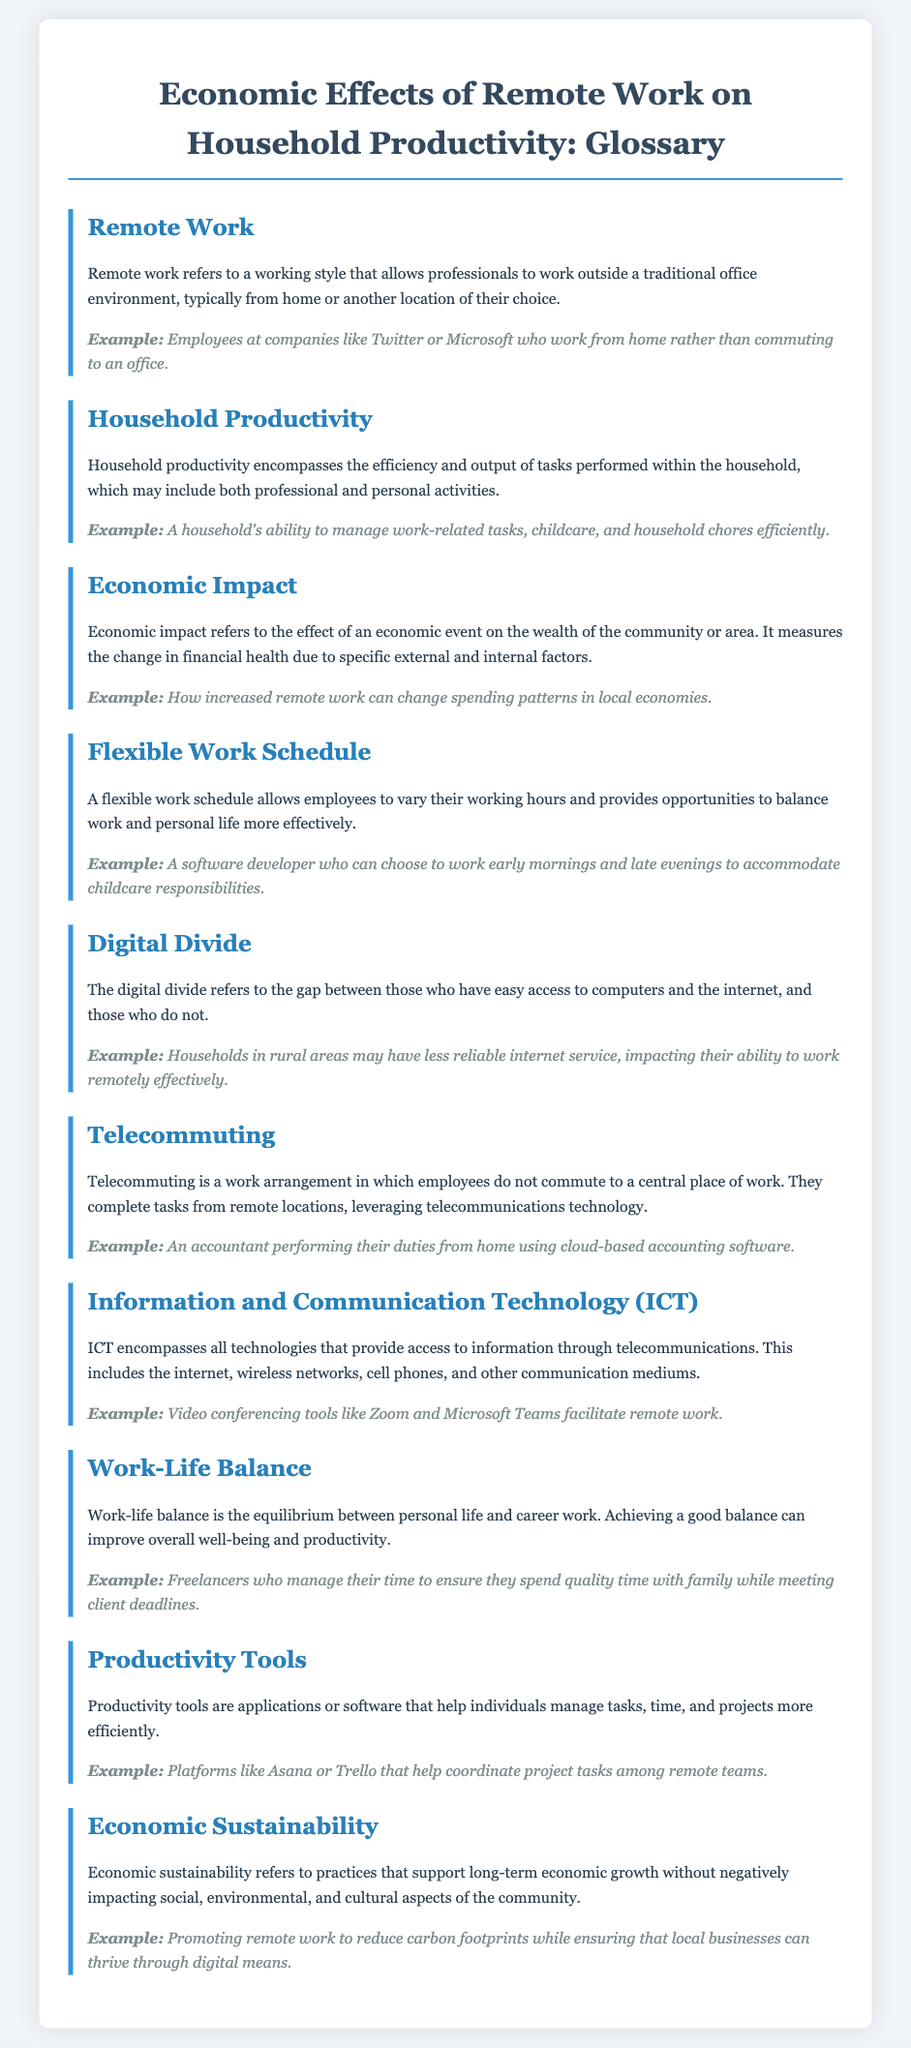What is remote work? Remote work is defined in the document as a working style that allows professionals to work outside a traditional office environment.
Answer: A working style that allows professionals to work outside a traditional office environment What encompasses household productivity? The definition states that household productivity includes the efficiency and output of tasks performed within the household.
Answer: The efficiency and output of tasks performed within the household What is the economic impact? The document explains that economic impact refers to the effect of an economic event on the wealth of the community or area.
Answer: The effect of an economic event on the wealth of the community or area Give an example of digital divide. The glossary provides the example of households in rural areas having less reliable internet service.
Answer: Households in rural areas may have less reliable internet service What tools help manage tasks and projects? The document lists productivity tools as applications or software that assist in managing tasks.
Answer: Applications or software that help manage tasks What is the aim of economic sustainability? The document defines economic sustainability as practices that support long-term economic growth without negatively impacting certain aspects.
Answer: Practices that support long-term economic growth without negatively impacting social, environmental, and cultural aspects What is a flexible work schedule? This term is defined in the document as a schedule that allows employees to vary their working hours.
Answer: A schedule that allows employees to vary their working hours Where does telecommuting occur? The definition specifies that telecommuting occurs in locations other than a central place of work.
Answer: In locations other than a central place of work What does ICT stand for? The document refers to the term ICT, which encompasses all technologies that provide access to information through telecommunications.
Answer: Information and Communication Technology 